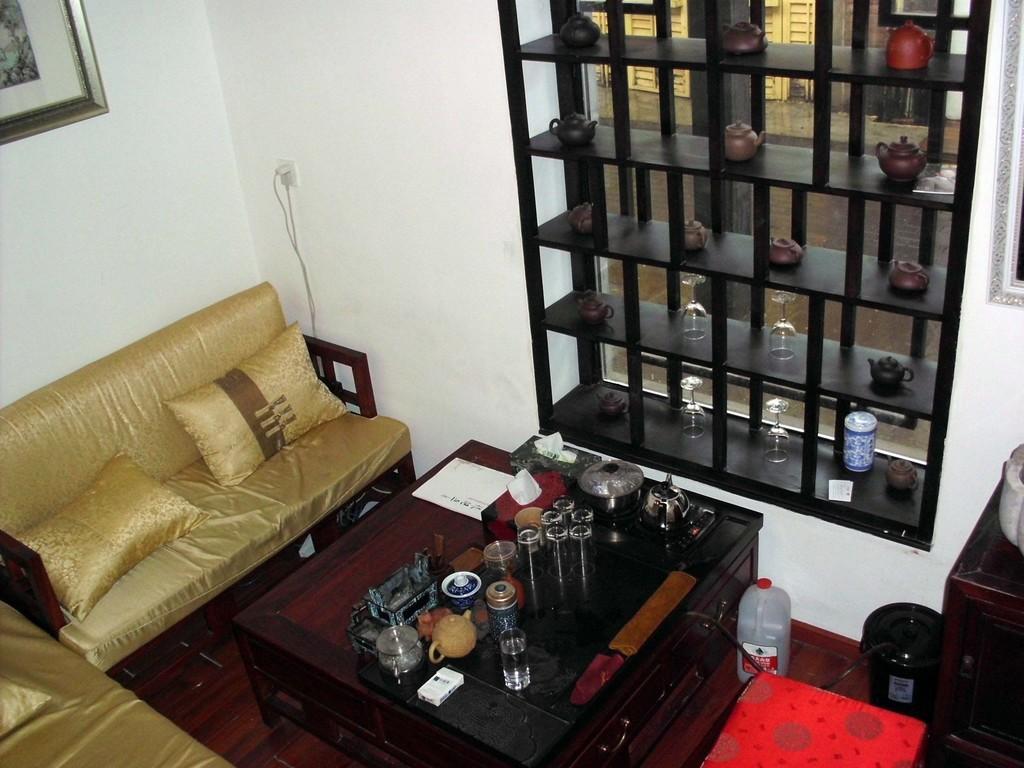Can you describe this image briefly? In this picture we can see a sofa. These are the pillows. This is table. On the table there are glasses and bottles. This is floor. On the background there is a wall and this is frame. 